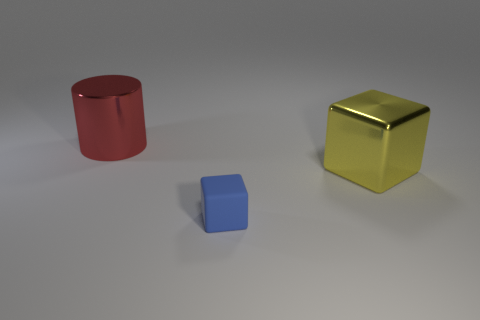How many tiny objects are cylinders or blue things?
Provide a succinct answer. 1. There is a object that is in front of the large thing in front of the big red cylinder; what is its material?
Offer a terse response. Rubber. Is there another yellow cube made of the same material as the large cube?
Offer a very short reply. No. Are the tiny object and the large thing that is right of the cylinder made of the same material?
Give a very brief answer. No. There is a metallic object that is the same size as the metallic block; what color is it?
Provide a short and direct response. Red. There is a metallic object in front of the large thing that is behind the yellow metal cube; what size is it?
Provide a succinct answer. Large. Does the cylinder have the same color as the cube in front of the large yellow metallic block?
Your answer should be very brief. No. Are there fewer objects that are to the left of the big cube than tiny blue matte things?
Provide a succinct answer. No. What number of other objects are there of the same size as the red metallic object?
Your response must be concise. 1. There is a big object that is in front of the red metallic cylinder; is it the same shape as the red thing?
Provide a succinct answer. No. 